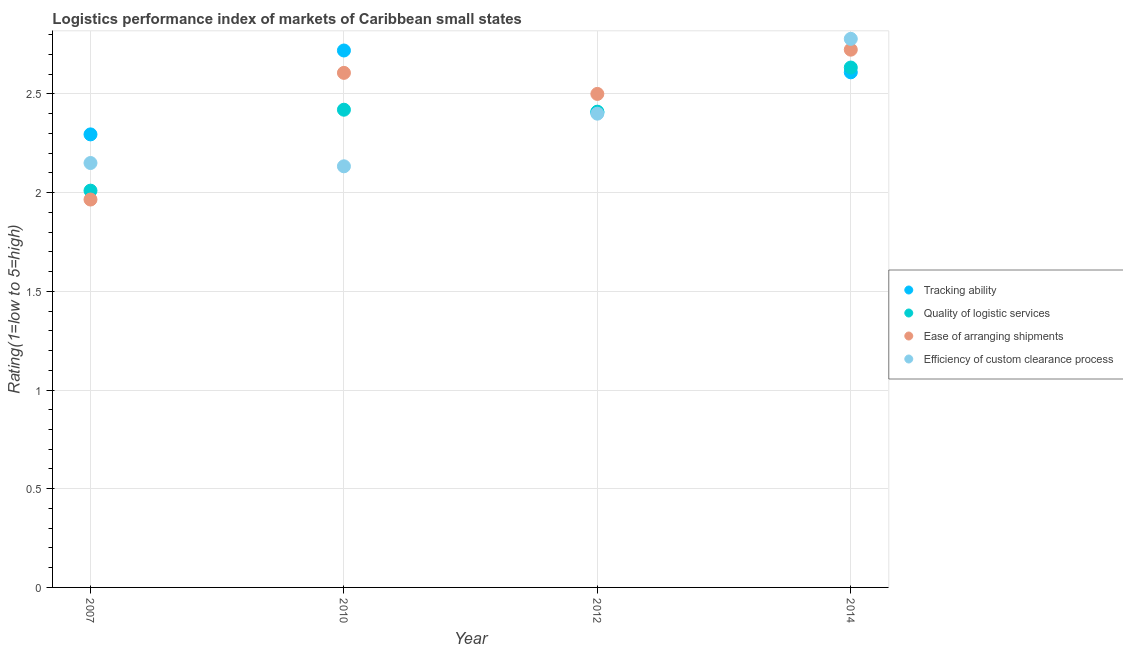How many different coloured dotlines are there?
Your response must be concise. 4. What is the lpi rating of tracking ability in 2010?
Make the answer very short. 2.72. Across all years, what is the maximum lpi rating of quality of logistic services?
Offer a very short reply. 2.63. Across all years, what is the minimum lpi rating of efficiency of custom clearance process?
Provide a succinct answer. 2.13. In which year was the lpi rating of efficiency of custom clearance process maximum?
Give a very brief answer. 2014. In which year was the lpi rating of efficiency of custom clearance process minimum?
Your response must be concise. 2010. What is the total lpi rating of efficiency of custom clearance process in the graph?
Give a very brief answer. 9.46. What is the difference between the lpi rating of ease of arranging shipments in 2007 and that in 2012?
Your response must be concise. -0.53. What is the difference between the lpi rating of ease of arranging shipments in 2010 and the lpi rating of quality of logistic services in 2012?
Offer a terse response. 0.2. What is the average lpi rating of efficiency of custom clearance process per year?
Keep it short and to the point. 2.37. In the year 2007, what is the difference between the lpi rating of efficiency of custom clearance process and lpi rating of ease of arranging shipments?
Your answer should be very brief. 0.18. What is the ratio of the lpi rating of efficiency of custom clearance process in 2012 to that in 2014?
Offer a terse response. 0.86. Is the lpi rating of ease of arranging shipments in 2007 less than that in 2014?
Ensure brevity in your answer.  Yes. Is the difference between the lpi rating of tracking ability in 2007 and 2014 greater than the difference between the lpi rating of quality of logistic services in 2007 and 2014?
Provide a succinct answer. Yes. What is the difference between the highest and the second highest lpi rating of efficiency of custom clearance process?
Your response must be concise. 0.38. What is the difference between the highest and the lowest lpi rating of ease of arranging shipments?
Offer a terse response. 0.76. In how many years, is the lpi rating of quality of logistic services greater than the average lpi rating of quality of logistic services taken over all years?
Make the answer very short. 3. Is it the case that in every year, the sum of the lpi rating of ease of arranging shipments and lpi rating of tracking ability is greater than the sum of lpi rating of efficiency of custom clearance process and lpi rating of quality of logistic services?
Your answer should be compact. No. Does the lpi rating of efficiency of custom clearance process monotonically increase over the years?
Your response must be concise. No. Is the lpi rating of quality of logistic services strictly less than the lpi rating of tracking ability over the years?
Give a very brief answer. No. How many dotlines are there?
Give a very brief answer. 4. How many years are there in the graph?
Your response must be concise. 4. Are the values on the major ticks of Y-axis written in scientific E-notation?
Provide a succinct answer. No. Does the graph contain any zero values?
Offer a very short reply. No. Where does the legend appear in the graph?
Make the answer very short. Center right. How are the legend labels stacked?
Ensure brevity in your answer.  Vertical. What is the title of the graph?
Provide a succinct answer. Logistics performance index of markets of Caribbean small states. Does "Tertiary schools" appear as one of the legend labels in the graph?
Ensure brevity in your answer.  No. What is the label or title of the Y-axis?
Offer a terse response. Rating(1=low to 5=high). What is the Rating(1=low to 5=high) of Tracking ability in 2007?
Make the answer very short. 2.29. What is the Rating(1=low to 5=high) in Quality of logistic services in 2007?
Provide a short and direct response. 2.01. What is the Rating(1=low to 5=high) in Ease of arranging shipments in 2007?
Ensure brevity in your answer.  1.97. What is the Rating(1=low to 5=high) of Efficiency of custom clearance process in 2007?
Make the answer very short. 2.15. What is the Rating(1=low to 5=high) of Tracking ability in 2010?
Provide a succinct answer. 2.72. What is the Rating(1=low to 5=high) of Quality of logistic services in 2010?
Ensure brevity in your answer.  2.42. What is the Rating(1=low to 5=high) in Ease of arranging shipments in 2010?
Your answer should be very brief. 2.61. What is the Rating(1=low to 5=high) in Efficiency of custom clearance process in 2010?
Make the answer very short. 2.13. What is the Rating(1=low to 5=high) in Tracking ability in 2012?
Your answer should be very brief. 2.41. What is the Rating(1=low to 5=high) in Quality of logistic services in 2012?
Your answer should be very brief. 2.41. What is the Rating(1=low to 5=high) of Tracking ability in 2014?
Your response must be concise. 2.61. What is the Rating(1=low to 5=high) of Quality of logistic services in 2014?
Make the answer very short. 2.63. What is the Rating(1=low to 5=high) of Ease of arranging shipments in 2014?
Ensure brevity in your answer.  2.72. What is the Rating(1=low to 5=high) of Efficiency of custom clearance process in 2014?
Keep it short and to the point. 2.78. Across all years, what is the maximum Rating(1=low to 5=high) of Tracking ability?
Give a very brief answer. 2.72. Across all years, what is the maximum Rating(1=low to 5=high) of Quality of logistic services?
Offer a very short reply. 2.63. Across all years, what is the maximum Rating(1=low to 5=high) in Ease of arranging shipments?
Give a very brief answer. 2.72. Across all years, what is the maximum Rating(1=low to 5=high) in Efficiency of custom clearance process?
Your answer should be very brief. 2.78. Across all years, what is the minimum Rating(1=low to 5=high) in Tracking ability?
Offer a terse response. 2.29. Across all years, what is the minimum Rating(1=low to 5=high) in Quality of logistic services?
Your answer should be very brief. 2.01. Across all years, what is the minimum Rating(1=low to 5=high) in Ease of arranging shipments?
Offer a terse response. 1.97. Across all years, what is the minimum Rating(1=low to 5=high) in Efficiency of custom clearance process?
Your answer should be very brief. 2.13. What is the total Rating(1=low to 5=high) of Tracking ability in the graph?
Your answer should be very brief. 10.03. What is the total Rating(1=low to 5=high) of Quality of logistic services in the graph?
Your response must be concise. 9.47. What is the total Rating(1=low to 5=high) of Ease of arranging shipments in the graph?
Offer a very short reply. 9.8. What is the total Rating(1=low to 5=high) in Efficiency of custom clearance process in the graph?
Keep it short and to the point. 9.46. What is the difference between the Rating(1=low to 5=high) in Tracking ability in 2007 and that in 2010?
Provide a short and direct response. -0.42. What is the difference between the Rating(1=low to 5=high) in Quality of logistic services in 2007 and that in 2010?
Offer a very short reply. -0.41. What is the difference between the Rating(1=low to 5=high) of Ease of arranging shipments in 2007 and that in 2010?
Ensure brevity in your answer.  -0.64. What is the difference between the Rating(1=low to 5=high) in Efficiency of custom clearance process in 2007 and that in 2010?
Provide a short and direct response. 0.02. What is the difference between the Rating(1=low to 5=high) of Tracking ability in 2007 and that in 2012?
Your answer should be compact. -0.11. What is the difference between the Rating(1=low to 5=high) of Ease of arranging shipments in 2007 and that in 2012?
Provide a short and direct response. -0.54. What is the difference between the Rating(1=low to 5=high) in Efficiency of custom clearance process in 2007 and that in 2012?
Ensure brevity in your answer.  -0.25. What is the difference between the Rating(1=low to 5=high) in Tracking ability in 2007 and that in 2014?
Your answer should be compact. -0.31. What is the difference between the Rating(1=low to 5=high) in Quality of logistic services in 2007 and that in 2014?
Offer a terse response. -0.62. What is the difference between the Rating(1=low to 5=high) of Ease of arranging shipments in 2007 and that in 2014?
Offer a terse response. -0.76. What is the difference between the Rating(1=low to 5=high) in Efficiency of custom clearance process in 2007 and that in 2014?
Your response must be concise. -0.63. What is the difference between the Rating(1=low to 5=high) in Tracking ability in 2010 and that in 2012?
Offer a terse response. 0.31. What is the difference between the Rating(1=low to 5=high) in Quality of logistic services in 2010 and that in 2012?
Offer a terse response. 0.01. What is the difference between the Rating(1=low to 5=high) in Ease of arranging shipments in 2010 and that in 2012?
Offer a terse response. 0.11. What is the difference between the Rating(1=low to 5=high) of Efficiency of custom clearance process in 2010 and that in 2012?
Provide a succinct answer. -0.27. What is the difference between the Rating(1=low to 5=high) of Tracking ability in 2010 and that in 2014?
Provide a short and direct response. 0.11. What is the difference between the Rating(1=low to 5=high) in Quality of logistic services in 2010 and that in 2014?
Keep it short and to the point. -0.21. What is the difference between the Rating(1=low to 5=high) of Ease of arranging shipments in 2010 and that in 2014?
Offer a terse response. -0.12. What is the difference between the Rating(1=low to 5=high) in Efficiency of custom clearance process in 2010 and that in 2014?
Offer a very short reply. -0.65. What is the difference between the Rating(1=low to 5=high) in Tracking ability in 2012 and that in 2014?
Your answer should be compact. -0.2. What is the difference between the Rating(1=low to 5=high) in Quality of logistic services in 2012 and that in 2014?
Offer a very short reply. -0.22. What is the difference between the Rating(1=low to 5=high) in Ease of arranging shipments in 2012 and that in 2014?
Your answer should be compact. -0.22. What is the difference between the Rating(1=low to 5=high) of Efficiency of custom clearance process in 2012 and that in 2014?
Your answer should be compact. -0.38. What is the difference between the Rating(1=low to 5=high) of Tracking ability in 2007 and the Rating(1=low to 5=high) of Quality of logistic services in 2010?
Your response must be concise. -0.12. What is the difference between the Rating(1=low to 5=high) of Tracking ability in 2007 and the Rating(1=low to 5=high) of Ease of arranging shipments in 2010?
Provide a succinct answer. -0.31. What is the difference between the Rating(1=low to 5=high) of Tracking ability in 2007 and the Rating(1=low to 5=high) of Efficiency of custom clearance process in 2010?
Ensure brevity in your answer.  0.16. What is the difference between the Rating(1=low to 5=high) in Quality of logistic services in 2007 and the Rating(1=low to 5=high) in Ease of arranging shipments in 2010?
Keep it short and to the point. -0.6. What is the difference between the Rating(1=low to 5=high) in Quality of logistic services in 2007 and the Rating(1=low to 5=high) in Efficiency of custom clearance process in 2010?
Make the answer very short. -0.12. What is the difference between the Rating(1=low to 5=high) in Ease of arranging shipments in 2007 and the Rating(1=low to 5=high) in Efficiency of custom clearance process in 2010?
Ensure brevity in your answer.  -0.17. What is the difference between the Rating(1=low to 5=high) in Tracking ability in 2007 and the Rating(1=low to 5=high) in Quality of logistic services in 2012?
Offer a terse response. -0.12. What is the difference between the Rating(1=low to 5=high) of Tracking ability in 2007 and the Rating(1=low to 5=high) of Ease of arranging shipments in 2012?
Provide a succinct answer. -0.2. What is the difference between the Rating(1=low to 5=high) of Tracking ability in 2007 and the Rating(1=low to 5=high) of Efficiency of custom clearance process in 2012?
Your answer should be compact. -0.1. What is the difference between the Rating(1=low to 5=high) in Quality of logistic services in 2007 and the Rating(1=low to 5=high) in Ease of arranging shipments in 2012?
Offer a very short reply. -0.49. What is the difference between the Rating(1=low to 5=high) of Quality of logistic services in 2007 and the Rating(1=low to 5=high) of Efficiency of custom clearance process in 2012?
Provide a short and direct response. -0.39. What is the difference between the Rating(1=low to 5=high) of Ease of arranging shipments in 2007 and the Rating(1=low to 5=high) of Efficiency of custom clearance process in 2012?
Give a very brief answer. -0.43. What is the difference between the Rating(1=low to 5=high) in Tracking ability in 2007 and the Rating(1=low to 5=high) in Quality of logistic services in 2014?
Offer a very short reply. -0.34. What is the difference between the Rating(1=low to 5=high) in Tracking ability in 2007 and the Rating(1=low to 5=high) in Ease of arranging shipments in 2014?
Offer a very short reply. -0.43. What is the difference between the Rating(1=low to 5=high) in Tracking ability in 2007 and the Rating(1=low to 5=high) in Efficiency of custom clearance process in 2014?
Your answer should be compact. -0.48. What is the difference between the Rating(1=low to 5=high) of Quality of logistic services in 2007 and the Rating(1=low to 5=high) of Ease of arranging shipments in 2014?
Ensure brevity in your answer.  -0.71. What is the difference between the Rating(1=low to 5=high) of Quality of logistic services in 2007 and the Rating(1=low to 5=high) of Efficiency of custom clearance process in 2014?
Make the answer very short. -0.77. What is the difference between the Rating(1=low to 5=high) of Ease of arranging shipments in 2007 and the Rating(1=low to 5=high) of Efficiency of custom clearance process in 2014?
Provide a succinct answer. -0.81. What is the difference between the Rating(1=low to 5=high) in Tracking ability in 2010 and the Rating(1=low to 5=high) in Quality of logistic services in 2012?
Your answer should be very brief. 0.31. What is the difference between the Rating(1=low to 5=high) in Tracking ability in 2010 and the Rating(1=low to 5=high) in Ease of arranging shipments in 2012?
Your answer should be very brief. 0.22. What is the difference between the Rating(1=low to 5=high) in Tracking ability in 2010 and the Rating(1=low to 5=high) in Efficiency of custom clearance process in 2012?
Provide a succinct answer. 0.32. What is the difference between the Rating(1=low to 5=high) in Quality of logistic services in 2010 and the Rating(1=low to 5=high) in Ease of arranging shipments in 2012?
Offer a terse response. -0.08. What is the difference between the Rating(1=low to 5=high) in Ease of arranging shipments in 2010 and the Rating(1=low to 5=high) in Efficiency of custom clearance process in 2012?
Provide a short and direct response. 0.21. What is the difference between the Rating(1=low to 5=high) of Tracking ability in 2010 and the Rating(1=low to 5=high) of Quality of logistic services in 2014?
Offer a terse response. 0.09. What is the difference between the Rating(1=low to 5=high) in Tracking ability in 2010 and the Rating(1=low to 5=high) in Ease of arranging shipments in 2014?
Keep it short and to the point. -0. What is the difference between the Rating(1=low to 5=high) of Tracking ability in 2010 and the Rating(1=low to 5=high) of Efficiency of custom clearance process in 2014?
Offer a very short reply. -0.06. What is the difference between the Rating(1=low to 5=high) of Quality of logistic services in 2010 and the Rating(1=low to 5=high) of Ease of arranging shipments in 2014?
Your answer should be very brief. -0.3. What is the difference between the Rating(1=low to 5=high) in Quality of logistic services in 2010 and the Rating(1=low to 5=high) in Efficiency of custom clearance process in 2014?
Make the answer very short. -0.36. What is the difference between the Rating(1=low to 5=high) in Ease of arranging shipments in 2010 and the Rating(1=low to 5=high) in Efficiency of custom clearance process in 2014?
Provide a short and direct response. -0.17. What is the difference between the Rating(1=low to 5=high) of Tracking ability in 2012 and the Rating(1=low to 5=high) of Quality of logistic services in 2014?
Your answer should be very brief. -0.23. What is the difference between the Rating(1=low to 5=high) in Tracking ability in 2012 and the Rating(1=low to 5=high) in Ease of arranging shipments in 2014?
Give a very brief answer. -0.32. What is the difference between the Rating(1=low to 5=high) in Tracking ability in 2012 and the Rating(1=low to 5=high) in Efficiency of custom clearance process in 2014?
Provide a short and direct response. -0.37. What is the difference between the Rating(1=low to 5=high) in Quality of logistic services in 2012 and the Rating(1=low to 5=high) in Ease of arranging shipments in 2014?
Your answer should be very brief. -0.31. What is the difference between the Rating(1=low to 5=high) of Quality of logistic services in 2012 and the Rating(1=low to 5=high) of Efficiency of custom clearance process in 2014?
Your response must be concise. -0.37. What is the difference between the Rating(1=low to 5=high) of Ease of arranging shipments in 2012 and the Rating(1=low to 5=high) of Efficiency of custom clearance process in 2014?
Provide a short and direct response. -0.28. What is the average Rating(1=low to 5=high) in Tracking ability per year?
Offer a very short reply. 2.51. What is the average Rating(1=low to 5=high) of Quality of logistic services per year?
Keep it short and to the point. 2.37. What is the average Rating(1=low to 5=high) of Ease of arranging shipments per year?
Offer a terse response. 2.45. What is the average Rating(1=low to 5=high) of Efficiency of custom clearance process per year?
Offer a terse response. 2.37. In the year 2007, what is the difference between the Rating(1=low to 5=high) of Tracking ability and Rating(1=low to 5=high) of Quality of logistic services?
Your answer should be compact. 0.28. In the year 2007, what is the difference between the Rating(1=low to 5=high) of Tracking ability and Rating(1=low to 5=high) of Ease of arranging shipments?
Provide a short and direct response. 0.33. In the year 2007, what is the difference between the Rating(1=low to 5=high) of Tracking ability and Rating(1=low to 5=high) of Efficiency of custom clearance process?
Offer a terse response. 0.14. In the year 2007, what is the difference between the Rating(1=low to 5=high) in Quality of logistic services and Rating(1=low to 5=high) in Ease of arranging shipments?
Give a very brief answer. 0.04. In the year 2007, what is the difference between the Rating(1=low to 5=high) in Quality of logistic services and Rating(1=low to 5=high) in Efficiency of custom clearance process?
Give a very brief answer. -0.14. In the year 2007, what is the difference between the Rating(1=low to 5=high) of Ease of arranging shipments and Rating(1=low to 5=high) of Efficiency of custom clearance process?
Provide a short and direct response. -0.18. In the year 2010, what is the difference between the Rating(1=low to 5=high) of Tracking ability and Rating(1=low to 5=high) of Ease of arranging shipments?
Give a very brief answer. 0.11. In the year 2010, what is the difference between the Rating(1=low to 5=high) in Tracking ability and Rating(1=low to 5=high) in Efficiency of custom clearance process?
Give a very brief answer. 0.59. In the year 2010, what is the difference between the Rating(1=low to 5=high) in Quality of logistic services and Rating(1=low to 5=high) in Ease of arranging shipments?
Your answer should be very brief. -0.19. In the year 2010, what is the difference between the Rating(1=low to 5=high) in Quality of logistic services and Rating(1=low to 5=high) in Efficiency of custom clearance process?
Give a very brief answer. 0.29. In the year 2010, what is the difference between the Rating(1=low to 5=high) of Ease of arranging shipments and Rating(1=low to 5=high) of Efficiency of custom clearance process?
Keep it short and to the point. 0.47. In the year 2012, what is the difference between the Rating(1=low to 5=high) in Tracking ability and Rating(1=low to 5=high) in Quality of logistic services?
Provide a succinct answer. -0. In the year 2012, what is the difference between the Rating(1=low to 5=high) in Tracking ability and Rating(1=low to 5=high) in Ease of arranging shipments?
Provide a succinct answer. -0.09. In the year 2012, what is the difference between the Rating(1=low to 5=high) of Tracking ability and Rating(1=low to 5=high) of Efficiency of custom clearance process?
Ensure brevity in your answer.  0.01. In the year 2012, what is the difference between the Rating(1=low to 5=high) of Quality of logistic services and Rating(1=low to 5=high) of Ease of arranging shipments?
Your answer should be very brief. -0.09. In the year 2012, what is the difference between the Rating(1=low to 5=high) of Quality of logistic services and Rating(1=low to 5=high) of Efficiency of custom clearance process?
Your answer should be compact. 0.01. In the year 2014, what is the difference between the Rating(1=low to 5=high) of Tracking ability and Rating(1=low to 5=high) of Quality of logistic services?
Provide a short and direct response. -0.02. In the year 2014, what is the difference between the Rating(1=low to 5=high) in Tracking ability and Rating(1=low to 5=high) in Ease of arranging shipments?
Your answer should be very brief. -0.11. In the year 2014, what is the difference between the Rating(1=low to 5=high) of Tracking ability and Rating(1=low to 5=high) of Efficiency of custom clearance process?
Provide a succinct answer. -0.17. In the year 2014, what is the difference between the Rating(1=low to 5=high) of Quality of logistic services and Rating(1=low to 5=high) of Ease of arranging shipments?
Your response must be concise. -0.09. In the year 2014, what is the difference between the Rating(1=low to 5=high) in Quality of logistic services and Rating(1=low to 5=high) in Efficiency of custom clearance process?
Your answer should be very brief. -0.15. In the year 2014, what is the difference between the Rating(1=low to 5=high) in Ease of arranging shipments and Rating(1=low to 5=high) in Efficiency of custom clearance process?
Make the answer very short. -0.05. What is the ratio of the Rating(1=low to 5=high) in Tracking ability in 2007 to that in 2010?
Keep it short and to the point. 0.84. What is the ratio of the Rating(1=low to 5=high) in Quality of logistic services in 2007 to that in 2010?
Your response must be concise. 0.83. What is the ratio of the Rating(1=low to 5=high) of Ease of arranging shipments in 2007 to that in 2010?
Make the answer very short. 0.75. What is the ratio of the Rating(1=low to 5=high) of Efficiency of custom clearance process in 2007 to that in 2010?
Offer a terse response. 1.01. What is the ratio of the Rating(1=low to 5=high) of Tracking ability in 2007 to that in 2012?
Your answer should be very brief. 0.95. What is the ratio of the Rating(1=low to 5=high) of Quality of logistic services in 2007 to that in 2012?
Provide a short and direct response. 0.83. What is the ratio of the Rating(1=low to 5=high) of Ease of arranging shipments in 2007 to that in 2012?
Offer a terse response. 0.79. What is the ratio of the Rating(1=low to 5=high) in Efficiency of custom clearance process in 2007 to that in 2012?
Your response must be concise. 0.9. What is the ratio of the Rating(1=low to 5=high) of Tracking ability in 2007 to that in 2014?
Keep it short and to the point. 0.88. What is the ratio of the Rating(1=low to 5=high) of Quality of logistic services in 2007 to that in 2014?
Make the answer very short. 0.76. What is the ratio of the Rating(1=low to 5=high) in Ease of arranging shipments in 2007 to that in 2014?
Offer a very short reply. 0.72. What is the ratio of the Rating(1=low to 5=high) in Efficiency of custom clearance process in 2007 to that in 2014?
Offer a terse response. 0.77. What is the ratio of the Rating(1=low to 5=high) in Tracking ability in 2010 to that in 2012?
Ensure brevity in your answer.  1.13. What is the ratio of the Rating(1=low to 5=high) in Ease of arranging shipments in 2010 to that in 2012?
Ensure brevity in your answer.  1.04. What is the ratio of the Rating(1=low to 5=high) of Tracking ability in 2010 to that in 2014?
Your answer should be compact. 1.04. What is the ratio of the Rating(1=low to 5=high) in Quality of logistic services in 2010 to that in 2014?
Ensure brevity in your answer.  0.92. What is the ratio of the Rating(1=low to 5=high) of Ease of arranging shipments in 2010 to that in 2014?
Make the answer very short. 0.96. What is the ratio of the Rating(1=low to 5=high) in Efficiency of custom clearance process in 2010 to that in 2014?
Ensure brevity in your answer.  0.77. What is the ratio of the Rating(1=low to 5=high) in Tracking ability in 2012 to that in 2014?
Offer a very short reply. 0.92. What is the ratio of the Rating(1=low to 5=high) of Quality of logistic services in 2012 to that in 2014?
Make the answer very short. 0.92. What is the ratio of the Rating(1=low to 5=high) in Ease of arranging shipments in 2012 to that in 2014?
Offer a very short reply. 0.92. What is the ratio of the Rating(1=low to 5=high) in Efficiency of custom clearance process in 2012 to that in 2014?
Your answer should be compact. 0.86. What is the difference between the highest and the second highest Rating(1=low to 5=high) of Tracking ability?
Keep it short and to the point. 0.11. What is the difference between the highest and the second highest Rating(1=low to 5=high) of Quality of logistic services?
Make the answer very short. 0.21. What is the difference between the highest and the second highest Rating(1=low to 5=high) of Ease of arranging shipments?
Your answer should be very brief. 0.12. What is the difference between the highest and the second highest Rating(1=low to 5=high) in Efficiency of custom clearance process?
Make the answer very short. 0.38. What is the difference between the highest and the lowest Rating(1=low to 5=high) of Tracking ability?
Make the answer very short. 0.42. What is the difference between the highest and the lowest Rating(1=low to 5=high) of Quality of logistic services?
Keep it short and to the point. 0.62. What is the difference between the highest and the lowest Rating(1=low to 5=high) of Ease of arranging shipments?
Your response must be concise. 0.76. What is the difference between the highest and the lowest Rating(1=low to 5=high) of Efficiency of custom clearance process?
Keep it short and to the point. 0.65. 